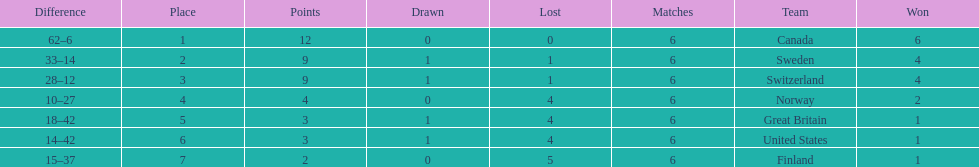Which team won more matches, finland or norway? Norway. 